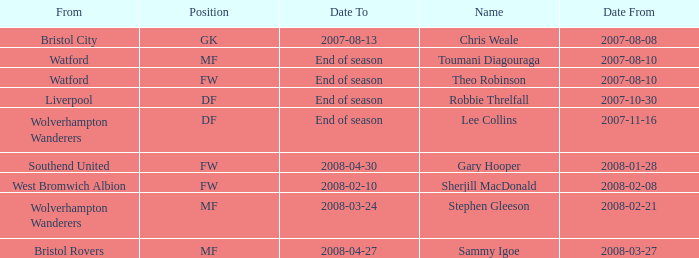What date did Toumani Diagouraga, who played position MF, start? 2007-08-10. 